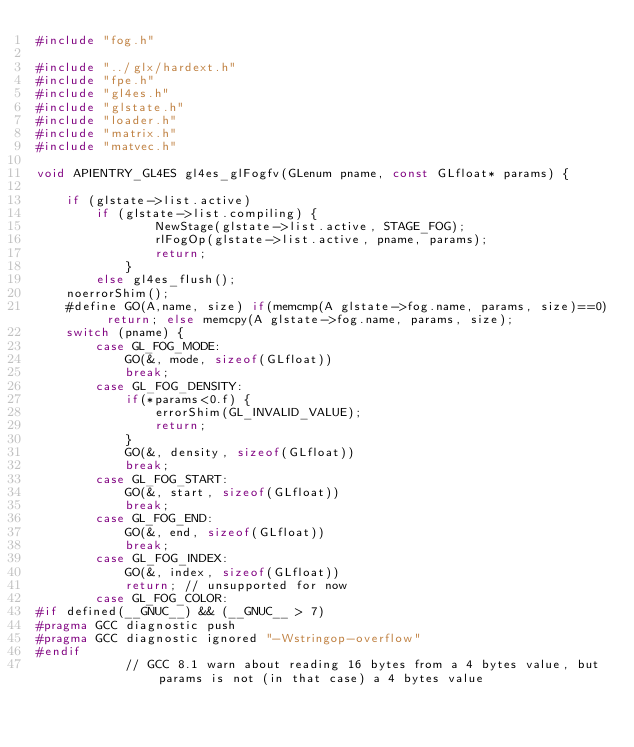Convert code to text. <code><loc_0><loc_0><loc_500><loc_500><_C_>#include "fog.h"

#include "../glx/hardext.h"
#include "fpe.h"
#include "gl4es.h"
#include "glstate.h"
#include "loader.h"
#include "matrix.h"
#include "matvec.h"

void APIENTRY_GL4ES gl4es_glFogfv(GLenum pname, const GLfloat* params) {

    if (glstate->list.active)
        if (glstate->list.compiling) {
                NewStage(glstate->list.active, STAGE_FOG);
                rlFogOp(glstate->list.active, pname, params);
                return;
            }
        else gl4es_flush();
    noerrorShim();
    #define GO(A,name, size) if(memcmp(A glstate->fog.name, params, size)==0) return; else memcpy(A glstate->fog.name, params, size);
    switch (pname) {
        case GL_FOG_MODE:
            GO(&, mode, sizeof(GLfloat))
            break;
        case GL_FOG_DENSITY:
            if(*params<0.f) {
                errorShim(GL_INVALID_VALUE);
                return;
            }
            GO(&, density, sizeof(GLfloat))
            break;
        case GL_FOG_START:
            GO(&, start, sizeof(GLfloat))
            break;
        case GL_FOG_END:
            GO(&, end, sizeof(GLfloat))
            break;
        case GL_FOG_INDEX:
            GO(&, index, sizeof(GLfloat))
            return; // unsupported for now
        case GL_FOG_COLOR:
#if defined(__GNUC__) && (__GNUC__ > 7)
#pragma GCC diagnostic push
#pragma GCC diagnostic ignored "-Wstringop-overflow"
#endif
            // GCC 8.1 warn about reading 16 bytes from a 4 bytes value, but params is not (in that case) a 4 bytes value</code> 